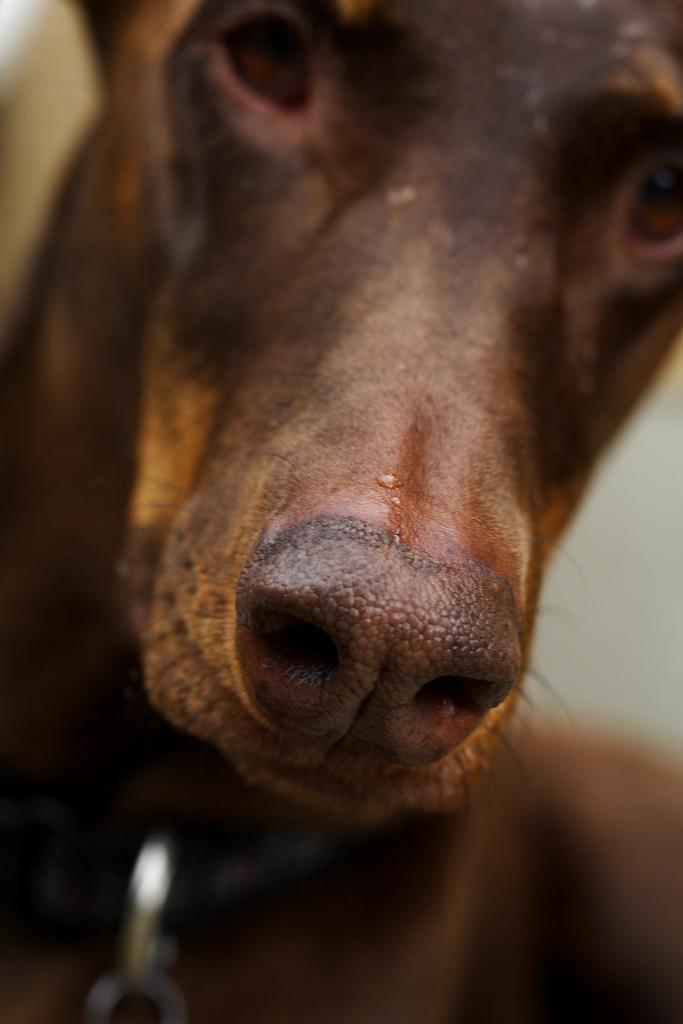In one or two sentences, can you explain what this image depicts? In this image we can see a dog in brown color. 